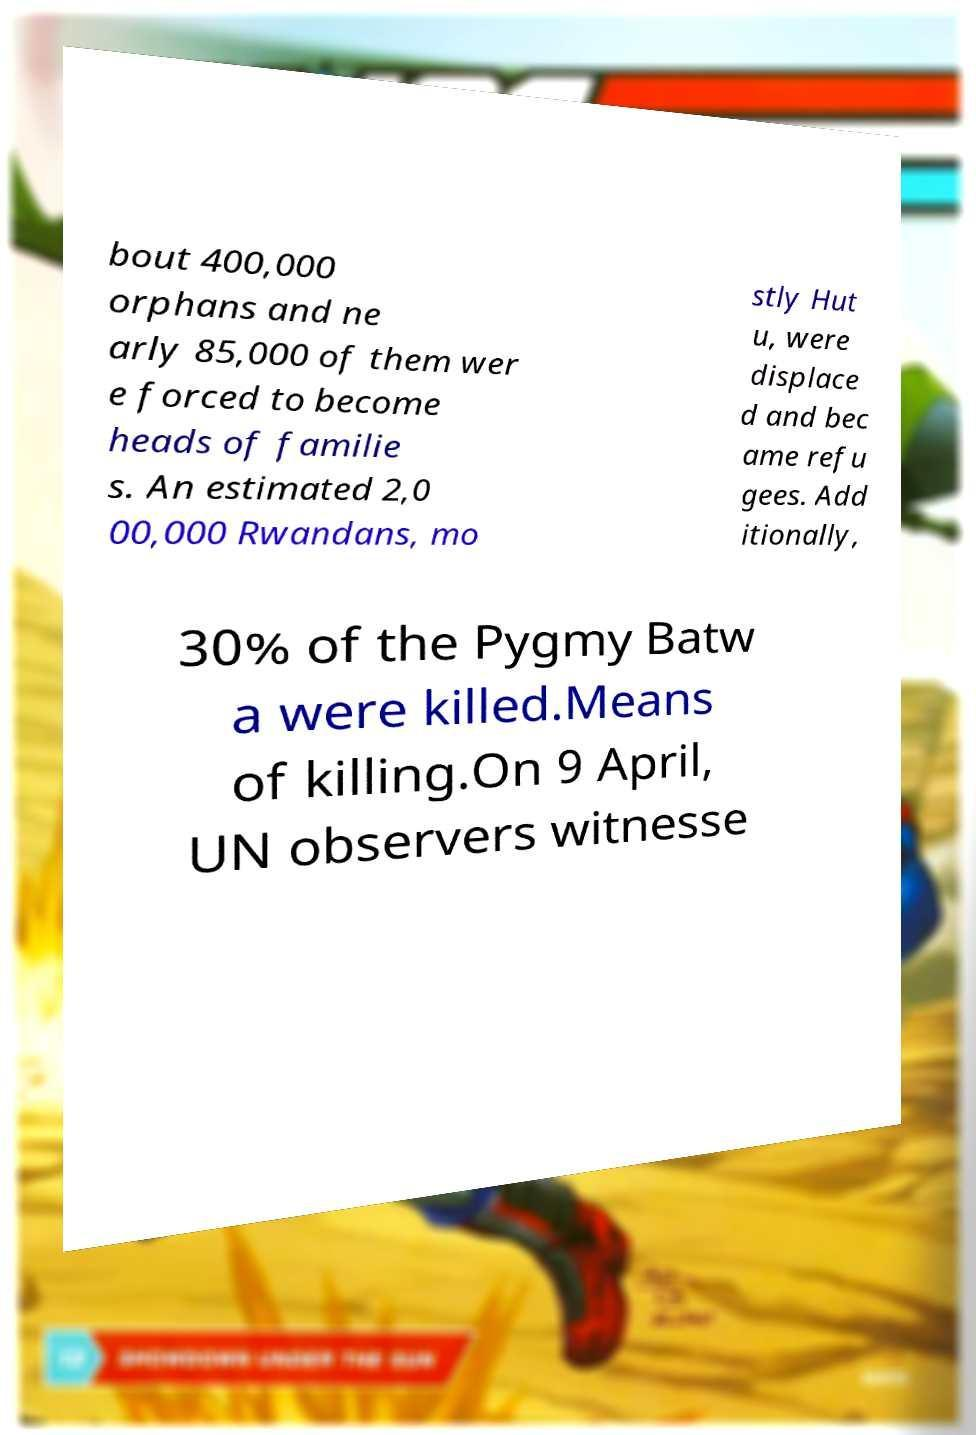There's text embedded in this image that I need extracted. Can you transcribe it verbatim? bout 400,000 orphans and ne arly 85,000 of them wer e forced to become heads of familie s. An estimated 2,0 00,000 Rwandans, mo stly Hut u, were displace d and bec ame refu gees. Add itionally, 30% of the Pygmy Batw a were killed.Means of killing.On 9 April, UN observers witnesse 